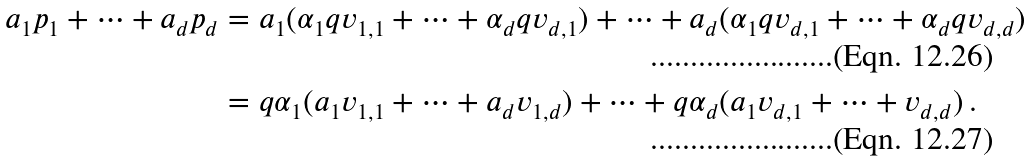<formula> <loc_0><loc_0><loc_500><loc_500>a _ { 1 } p _ { 1 } + \dots + a _ { d } p _ { d } & = a _ { 1 } ( \alpha _ { 1 } q v _ { 1 , 1 } + \dots + \alpha _ { d } q v _ { d , 1 } ) + \dots + a _ { d } ( \alpha _ { 1 } q v _ { d , 1 } + \dots + \alpha _ { d } q v _ { d , d } ) \\ & = q \alpha _ { 1 } ( a _ { 1 } v _ { 1 , 1 } + \dots + a _ { d } v _ { 1 , d } ) + \dots + q \alpha _ { d } ( a _ { 1 } v _ { d , 1 } + \dots + v _ { d , d } ) \, .</formula> 